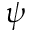Convert formula to latex. <formula><loc_0><loc_0><loc_500><loc_500>\psi</formula> 